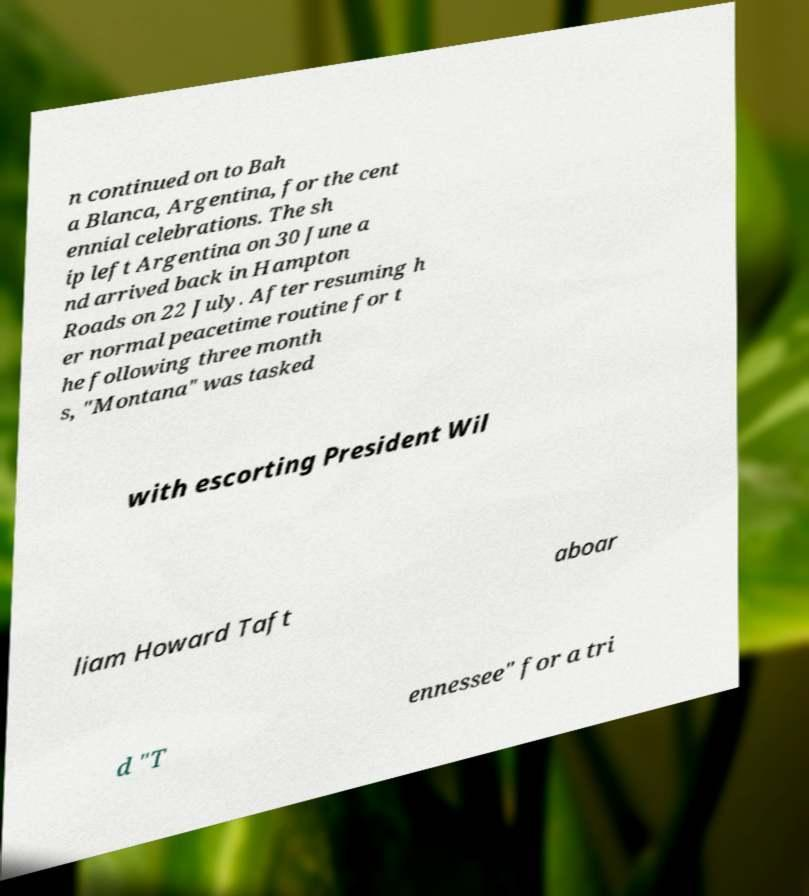Can you read and provide the text displayed in the image?This photo seems to have some interesting text. Can you extract and type it out for me? n continued on to Bah a Blanca, Argentina, for the cent ennial celebrations. The sh ip left Argentina on 30 June a nd arrived back in Hampton Roads on 22 July. After resuming h er normal peacetime routine for t he following three month s, "Montana" was tasked with escorting President Wil liam Howard Taft aboar d "T ennessee" for a tri 